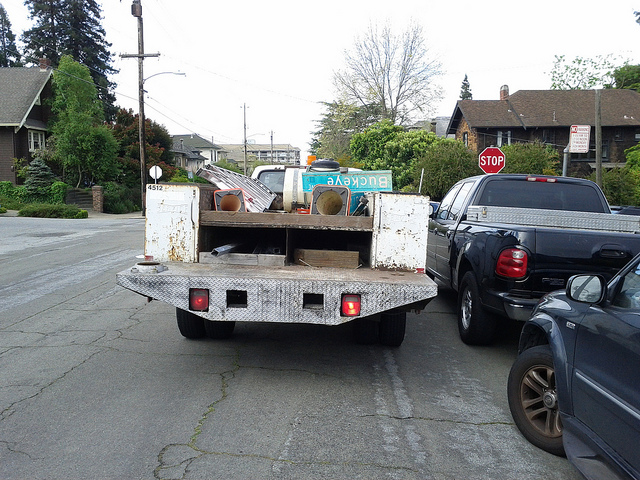Identify the text contained in this image. 4512 Buckeye STOP 